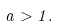Convert formula to latex. <formula><loc_0><loc_0><loc_500><loc_500>a > 1 .</formula> 